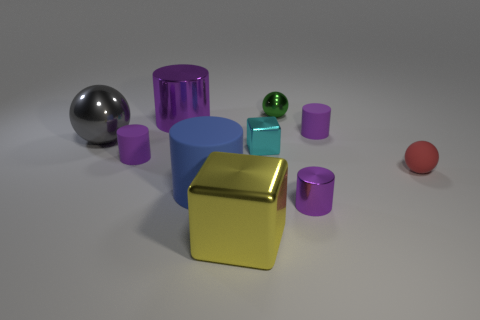There is a big yellow metallic object that is to the left of the green shiny object; is its shape the same as the tiny cyan thing?
Offer a terse response. Yes. What is the material of the other big object that is the same shape as the big blue rubber thing?
Offer a terse response. Metal. What number of tiny purple shiny objects have the same shape as the blue rubber object?
Ensure brevity in your answer.  1. Is the number of tiny things in front of the matte ball greater than the number of tiny metal cylinders in front of the big yellow metallic thing?
Provide a succinct answer. Yes. There is a large cylinder behind the rubber sphere; is it the same color as the tiny metallic cylinder?
Offer a very short reply. Yes. The green ball has what size?
Provide a succinct answer. Small. There is a blue thing that is the same size as the yellow object; what is it made of?
Provide a short and direct response. Rubber. What color is the matte object that is in front of the red ball?
Offer a terse response. Blue. What number of tiny green metallic things are there?
Keep it short and to the point. 1. Are there any big blue matte objects behind the small cylinder that is left of the small purple cylinder that is in front of the big blue cylinder?
Offer a terse response. No. 